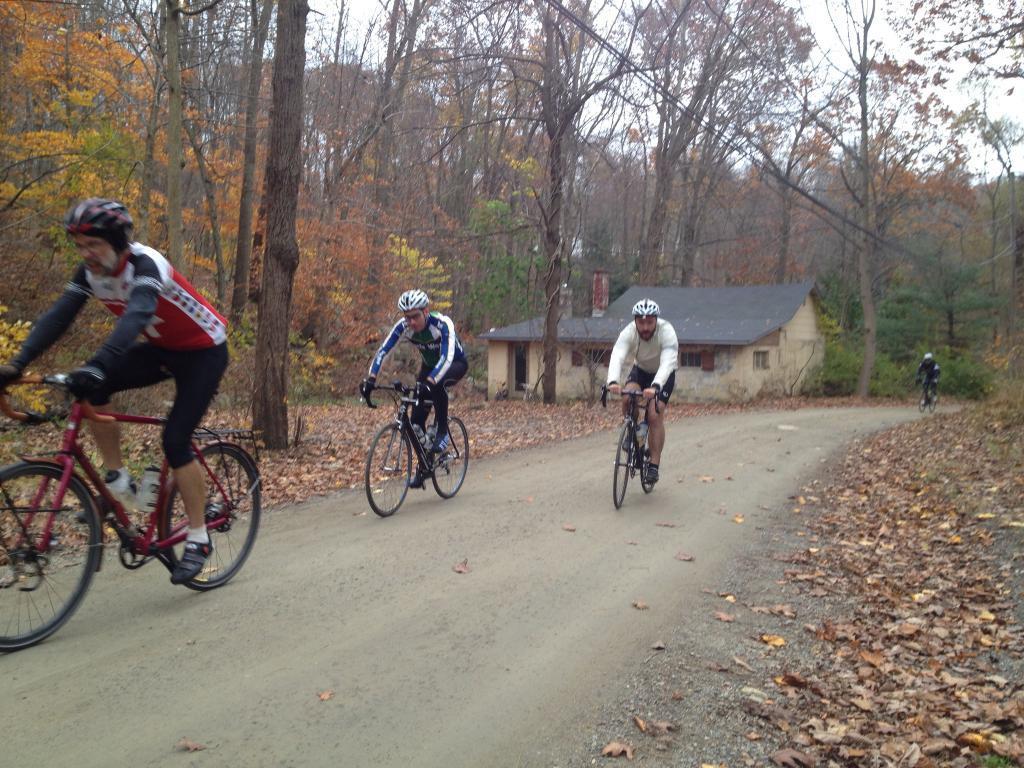Describe this image in one or two sentences. In the picture I can see people are riding bicycles on the road. These people are wearing helmets, clothes and footwear. In the background I can see trees, leaves on the ground and the sky. 